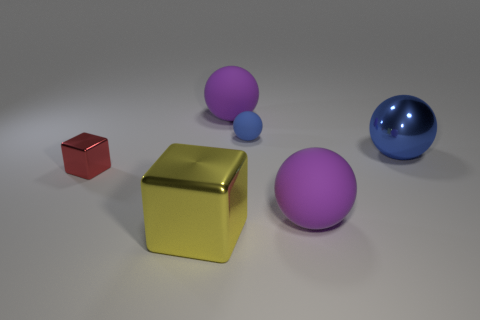The big purple thing that is behind the rubber thing that is in front of the tiny red block is made of what material?
Make the answer very short. Rubber. Does the tiny matte thing have the same color as the shiny ball?
Provide a short and direct response. Yes. There is another ball that is the same color as the large metallic sphere; what material is it?
Offer a terse response. Rubber. Is the large block made of the same material as the small block?
Your response must be concise. Yes. What size is the metal object that is right of the tiny red shiny thing and behind the large yellow metal block?
Offer a very short reply. Large. What is the shape of the metal thing that is the same size as the metal ball?
Offer a very short reply. Cube. The blue sphere on the right side of the rubber thing in front of the metallic block behind the yellow thing is made of what material?
Your answer should be very brief. Metal. Is the shape of the big purple object in front of the small red metallic thing the same as the blue thing that is left of the blue metallic thing?
Provide a succinct answer. Yes. Is the small thing left of the yellow metallic object made of the same material as the big purple object that is in front of the large blue thing?
Offer a terse response. No. There is a blue thing that is the same material as the tiny block; what is its shape?
Your response must be concise. Sphere. 